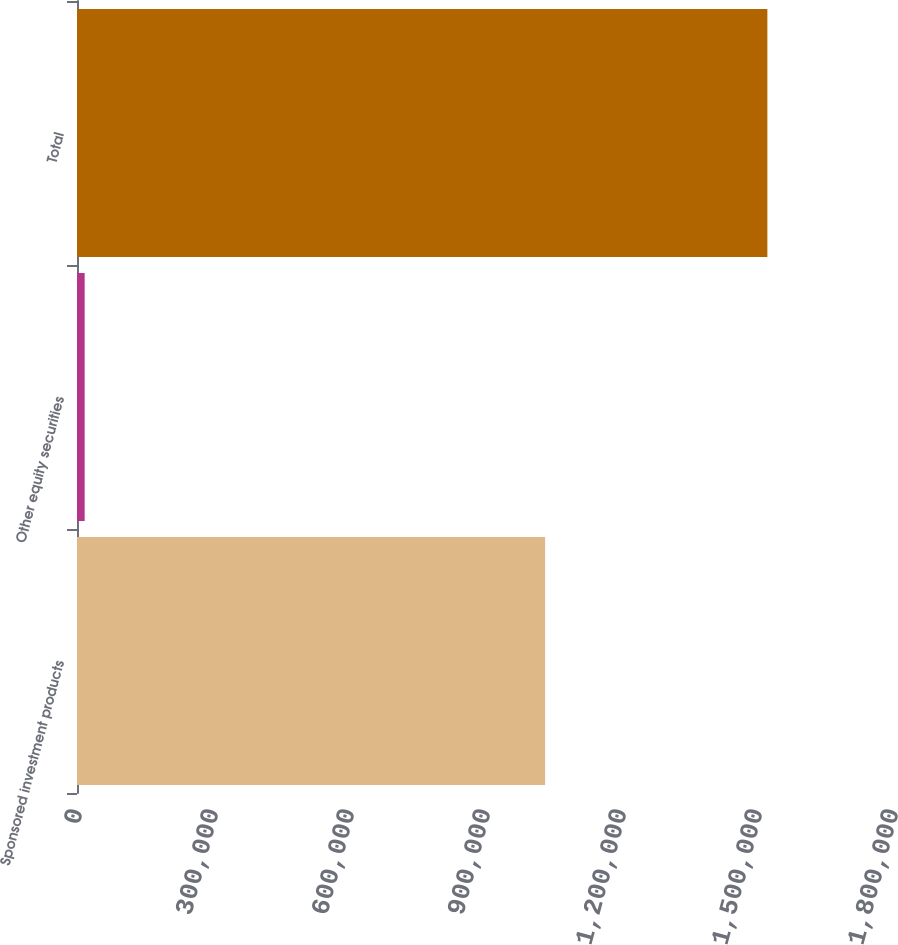<chart> <loc_0><loc_0><loc_500><loc_500><bar_chart><fcel>Sponsored investment products<fcel>Other equity securities<fcel>Total<nl><fcel>1.0326e+06<fcel>16931<fcel>1.52288e+06<nl></chart> 